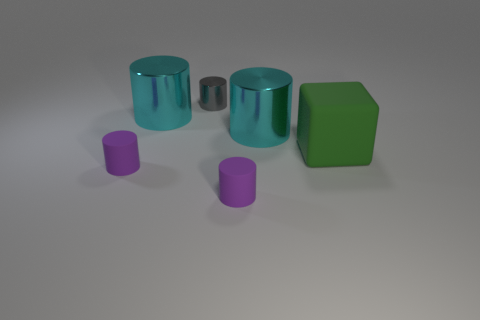Subtract all gray cylinders. How many cylinders are left? 4 Subtract all tiny gray cylinders. How many cylinders are left? 4 Subtract 1 cylinders. How many cylinders are left? 4 Subtract all yellow cylinders. Subtract all gray blocks. How many cylinders are left? 5 Add 1 green rubber objects. How many objects exist? 7 Subtract all cubes. How many objects are left? 5 Subtract all green rubber things. Subtract all blocks. How many objects are left? 4 Add 1 green matte things. How many green matte things are left? 2 Add 3 red blocks. How many red blocks exist? 3 Subtract 1 cyan cylinders. How many objects are left? 5 